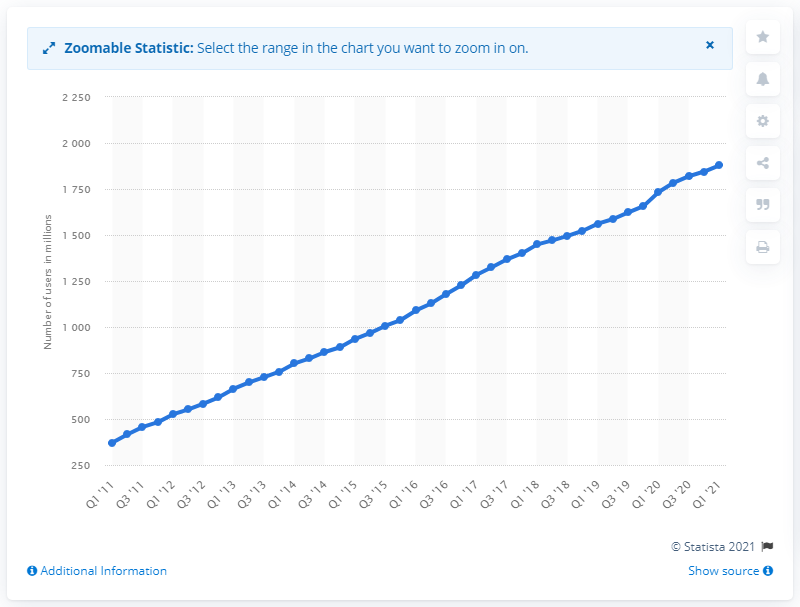List a handful of essential elements in this visual. Facebook had 1,878 daily active users in the first quarter of 2021. 